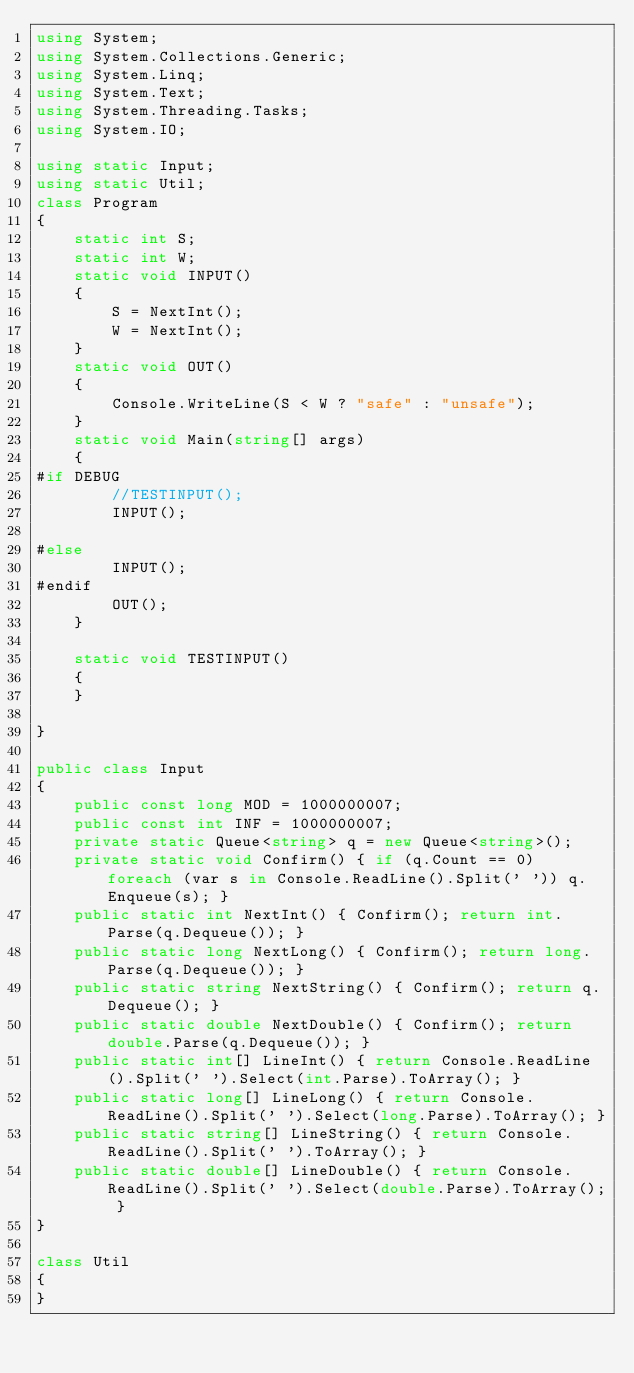<code> <loc_0><loc_0><loc_500><loc_500><_C#_>using System;
using System.Collections.Generic;
using System.Linq;
using System.Text;
using System.Threading.Tasks;
using System.IO;

using static Input;
using static Util;
class Program
{
    static int S;
    static int W;
    static void INPUT()
    {
        S = NextInt();
        W = NextInt();
    }
    static void OUT()
    {
        Console.WriteLine(S < W ? "safe" : "unsafe");
    }
    static void Main(string[] args)
    {
#if DEBUG  
        //TESTINPUT();
        INPUT();

#else
        INPUT();
#endif
        OUT();
    }

    static void TESTINPUT()
    {
    }

}

public class Input
{
    public const long MOD = 1000000007;
    public const int INF = 1000000007;
    private static Queue<string> q = new Queue<string>();
    private static void Confirm() { if (q.Count == 0) foreach (var s in Console.ReadLine().Split(' ')) q.Enqueue(s); }
    public static int NextInt() { Confirm(); return int.Parse(q.Dequeue()); }
    public static long NextLong() { Confirm(); return long.Parse(q.Dequeue()); }
    public static string NextString() { Confirm(); return q.Dequeue(); }
    public static double NextDouble() { Confirm(); return double.Parse(q.Dequeue()); }
    public static int[] LineInt() { return Console.ReadLine().Split(' ').Select(int.Parse).ToArray(); }
    public static long[] LineLong() { return Console.ReadLine().Split(' ').Select(long.Parse).ToArray(); }
    public static string[] LineString() { return Console.ReadLine().Split(' ').ToArray(); }
    public static double[] LineDouble() { return Console.ReadLine().Split(' ').Select(double.Parse).ToArray(); }
}

class Util
{
}


</code> 